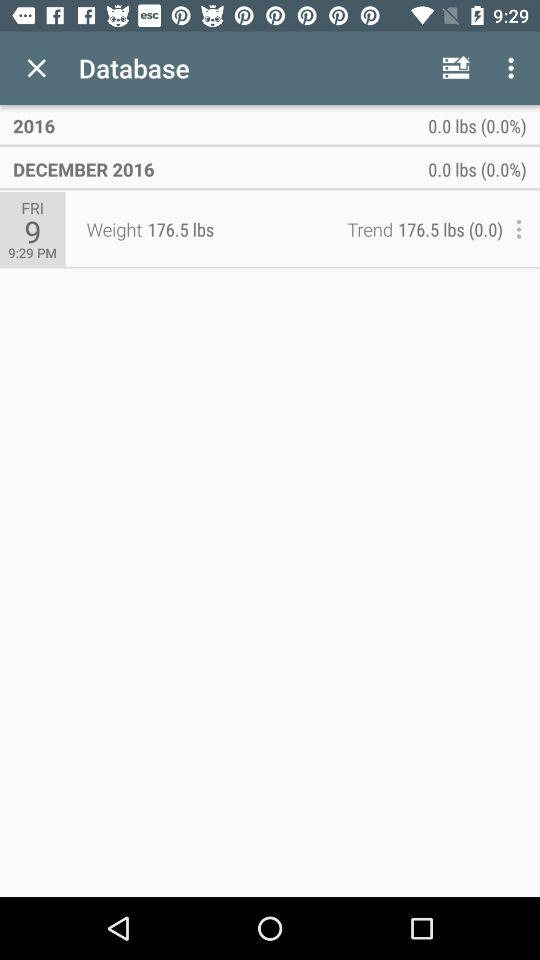What was the weight recorded in December 2016? The recorded weight was 176.5 lbs. 